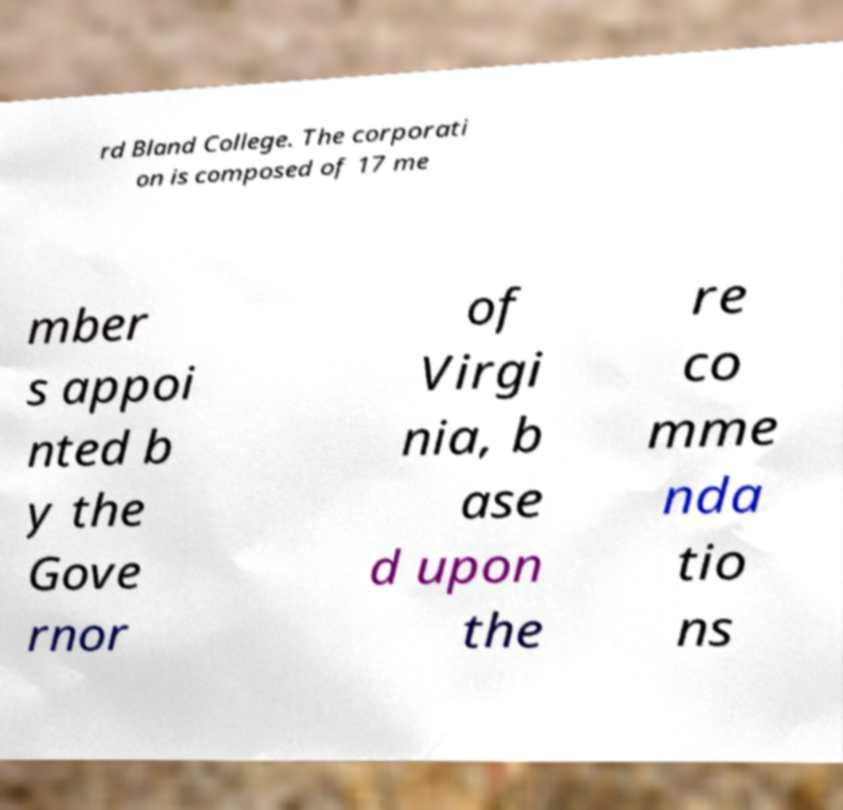There's text embedded in this image that I need extracted. Can you transcribe it verbatim? rd Bland College. The corporati on is composed of 17 me mber s appoi nted b y the Gove rnor of Virgi nia, b ase d upon the re co mme nda tio ns 